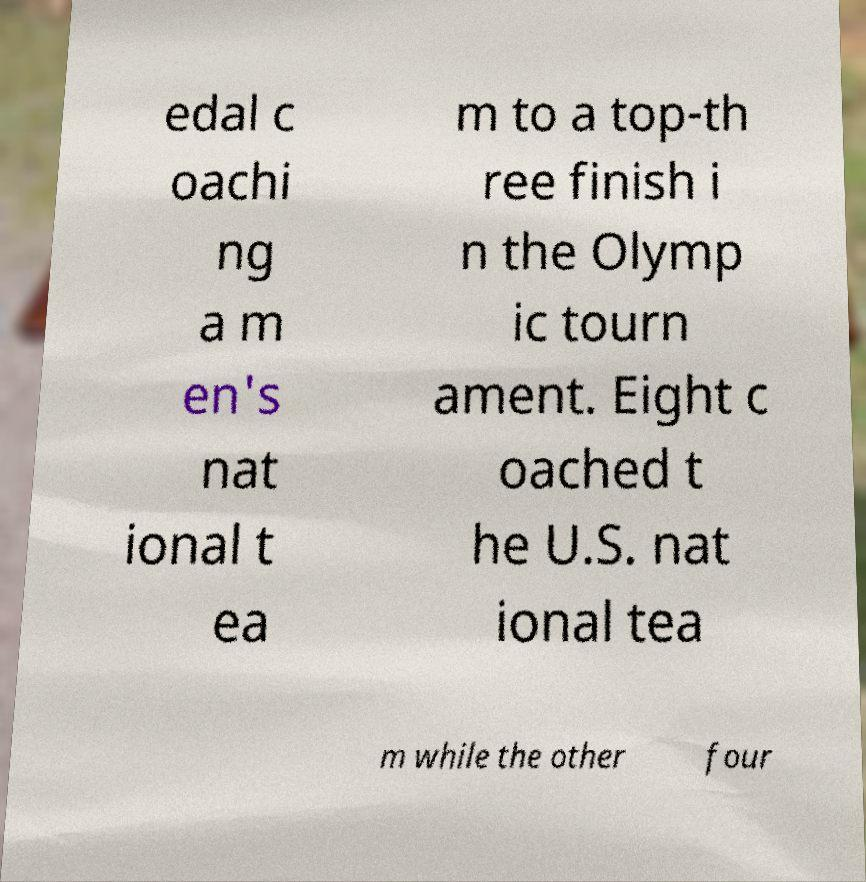Could you assist in decoding the text presented in this image and type it out clearly? edal c oachi ng a m en's nat ional t ea m to a top-th ree finish i n the Olymp ic tourn ament. Eight c oached t he U.S. nat ional tea m while the other four 